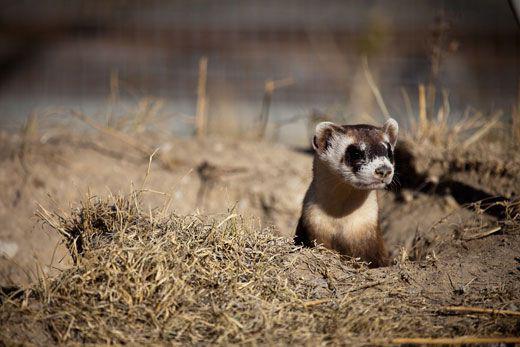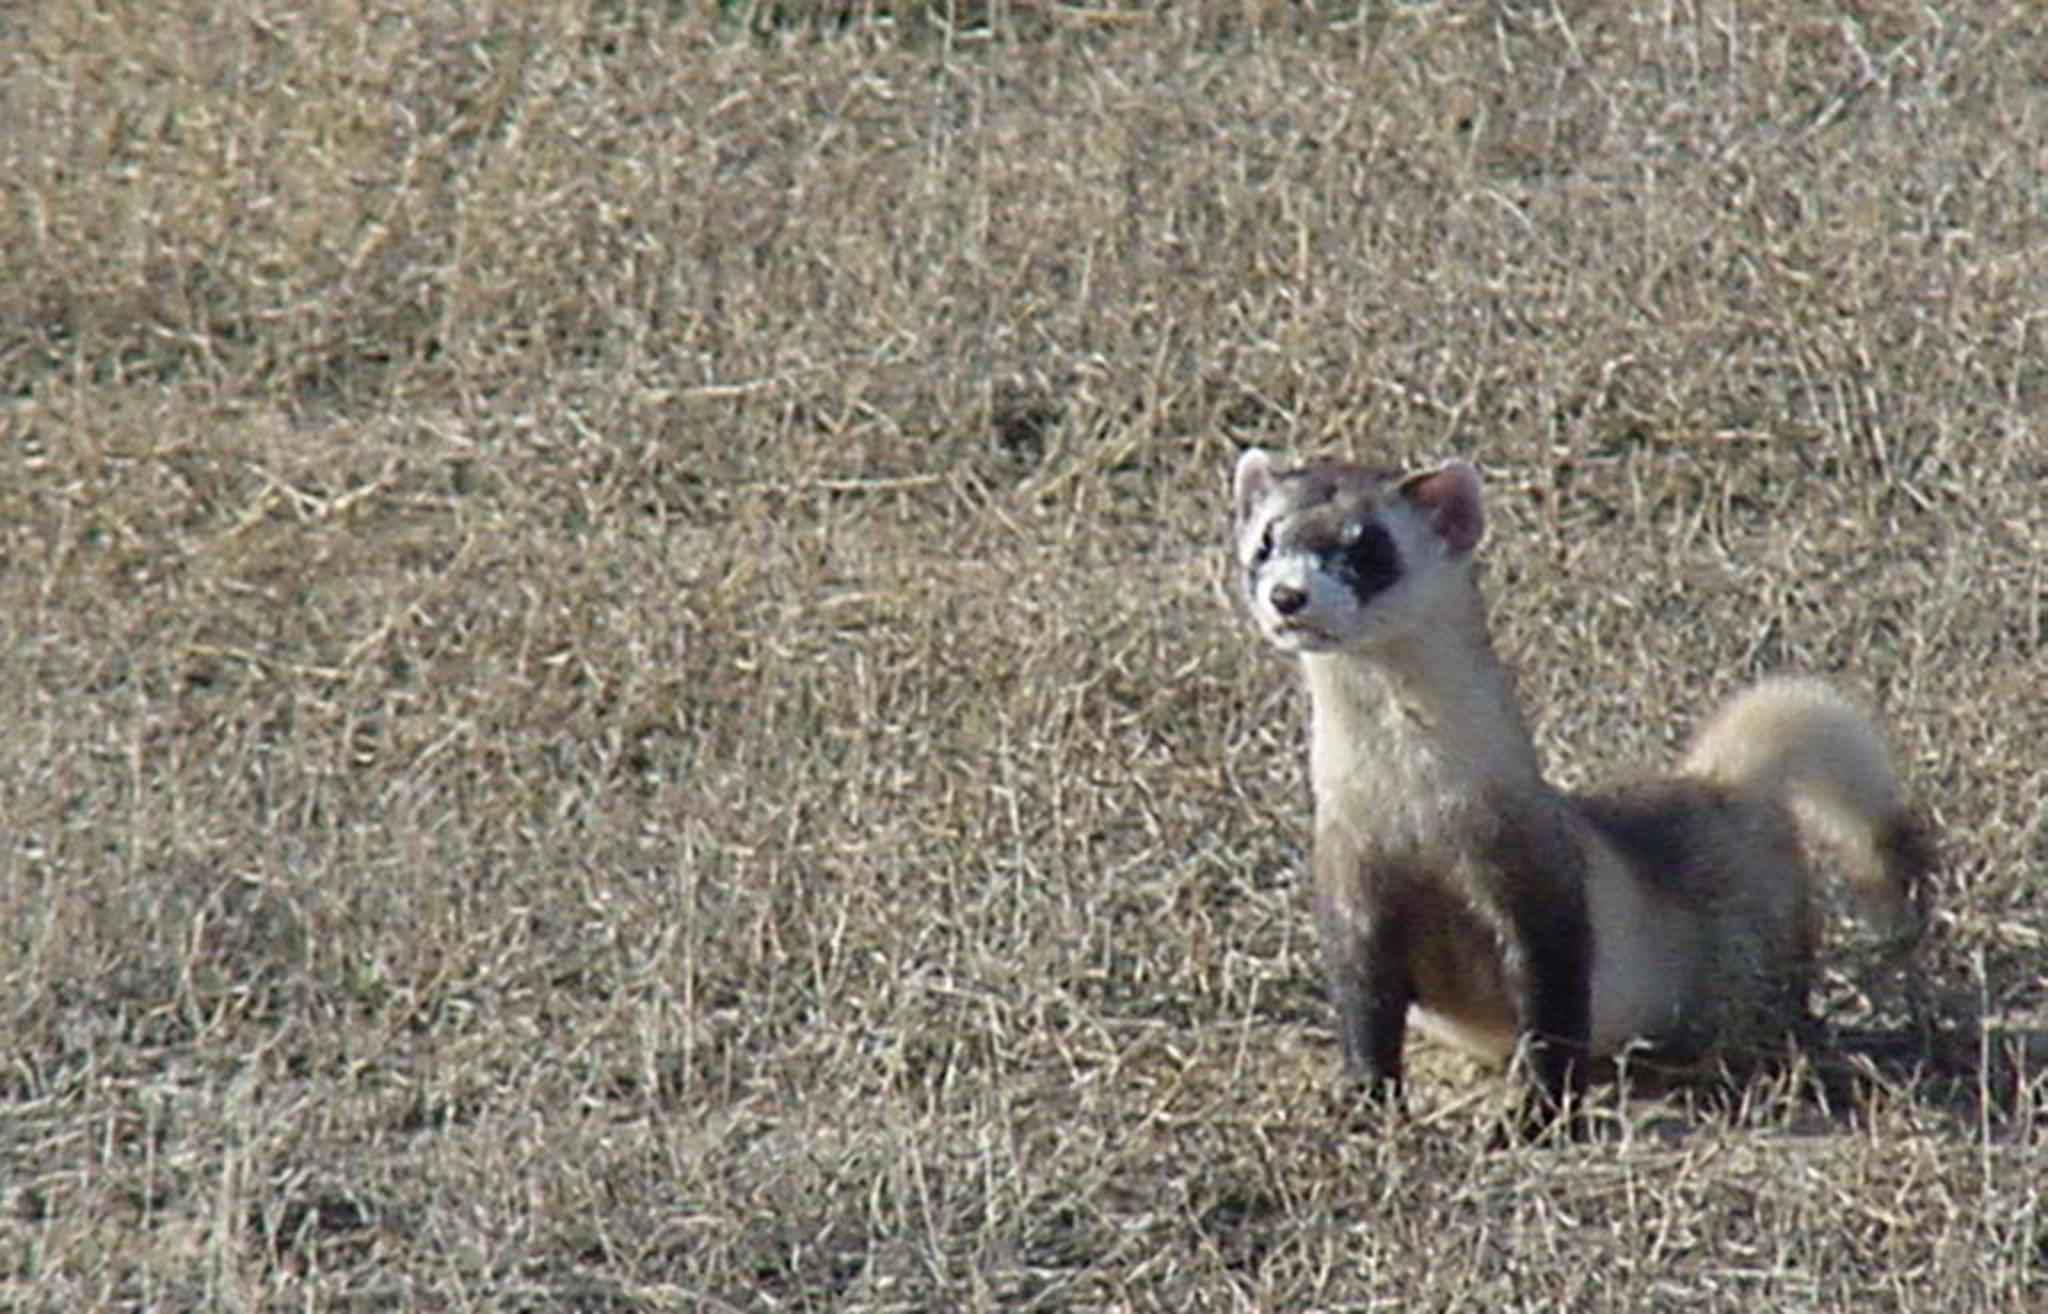The first image is the image on the left, the second image is the image on the right. Analyze the images presented: Is the assertion "In the image on the right, a small portion of the ferret's body is occluded by some of the grass." valid? Answer yes or no. Yes. 